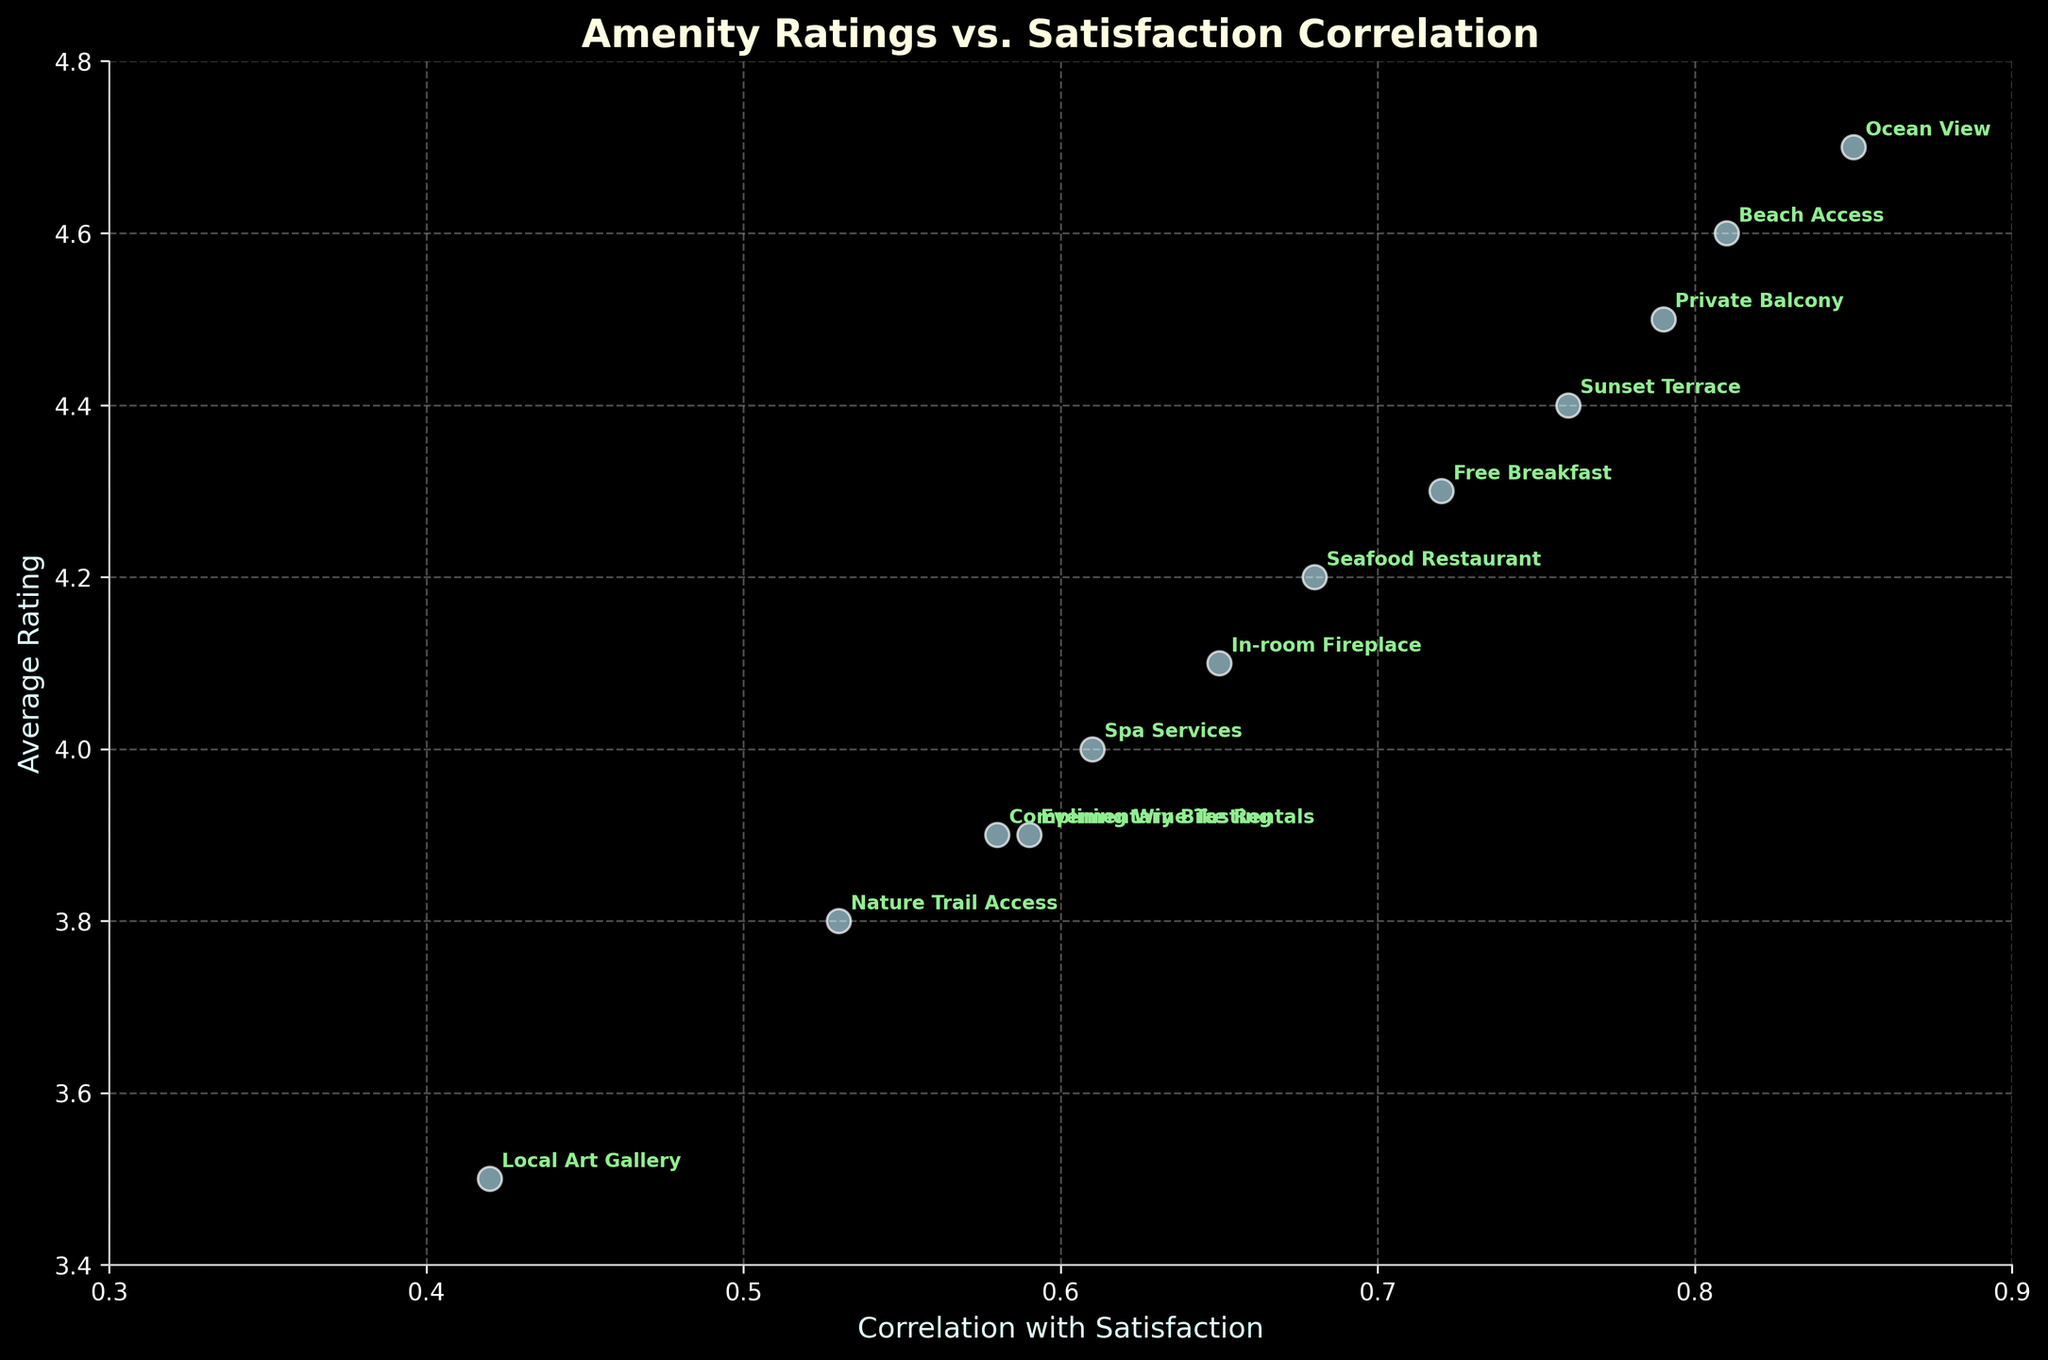What is the title of the figure? The title is usually found at the top of the figure. It describes the main content and purpose of the graph, which in this case shows the relationship between amenity ratings and satisfaction correlation.
Answer: Amenity Ratings vs. Satisfaction Correlation What are the labels for the X and Y axes? The labels identify what each axis represents. The X-axis label shows 'Correlation with Satisfaction' and the Y-axis label shows 'Average Rating,' both of which are related to amenities in the figure.
Answer: Correlation with Satisfaction, Average Rating Which amenity has the highest average rating? To find this, look at the Y-values and identify which point is at the highest position. 'Ocean View' has the highest Y-value, indicating the highest average rating.
Answer: Ocean View What is the correlation with satisfaction for 'Complimentary Bike Rentals'? Locate the 'Complimentary Bike Rentals' label on the plot, then check its position on the X-axis to determine its correlation value.
Answer: 0.58 How many amenities have a correlation with satisfaction greater than 0.75? Count the number of data points (amenities) whose positions on the X-axis are greater than 0.75. These amenities are 'Ocean View,' 'Beach Access,' 'Private Balcony,' and 'Sunset Terrace.'
Answer: 4 Which amenity has the lowest average rating and what is its value? Identify the data point that has the lowest position on the Y-axis, which corresponds to 'Local Art Gallery.' The Y-value provides its average rating.
Answer: Local Art Gallery, 3.5 How do the average ratings of 'Spa Services' and 'Evening Wine Tasting' compare? Locate both 'Spa Services' and 'Evening Wine Tasting' on the plot, then compare their positions on the Y-axis.
Answer: Spa Services is slightly higher than Evening Wine Tasting Which amenity has the highest correlation with overall satisfaction but has an average rating below 4.6? Look at the plot to find the highest X-values (correlations) and check their Y-values to identify if they are below 4.6. 'Sunset Terrace' and has a correlation of 0.76 but a rating of 4.4.
Answer: Sunset Terrace What is the combined average rating of 'Free Breakfast' and 'Beach Access'? Find the average ratings for 'Free Breakfast' and 'Beach Access' (4.3 and 4.6 respectively), then sum and average them. (4.3 + 4.6) / 2 = 4.45
Answer: 4.45 Which amenity is closest to the correlation value of 0.65? Identify the data points near 0.65 on the X-axis. 'In-room Fireplace' closely matches this value.
Answer: In-room Fireplace 